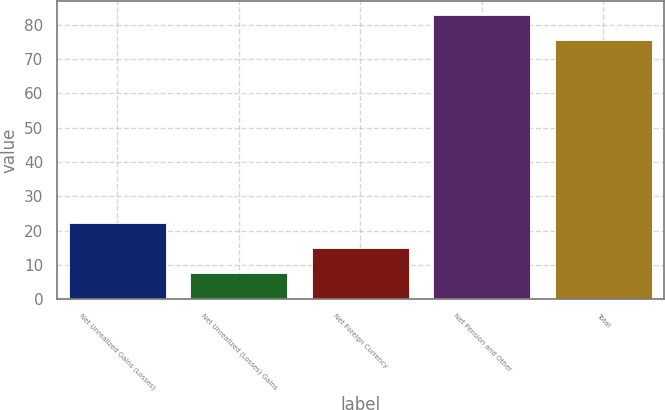Convert chart to OTSL. <chart><loc_0><loc_0><loc_500><loc_500><bar_chart><fcel>Net Unrealized Gains (Losses)<fcel>Net Unrealized (Losses) Gains<fcel>Net Foreign Currency<fcel>Net Pension and Other<fcel>Total<nl><fcel>22.2<fcel>7.6<fcel>14.9<fcel>82.7<fcel>75.4<nl></chart> 